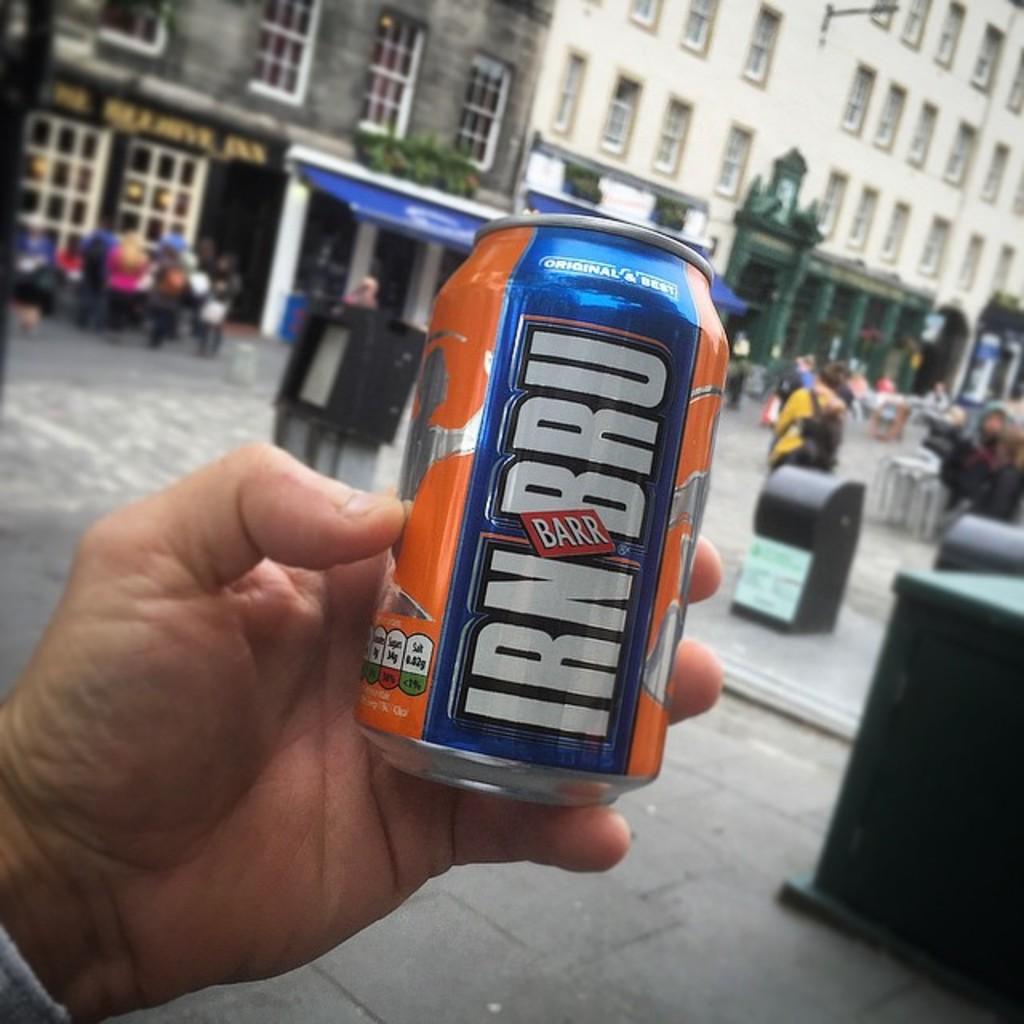How much salt is in this drink?
Ensure brevity in your answer.  Unanswerable. What is the brand name?
Offer a terse response. Irnbru. 